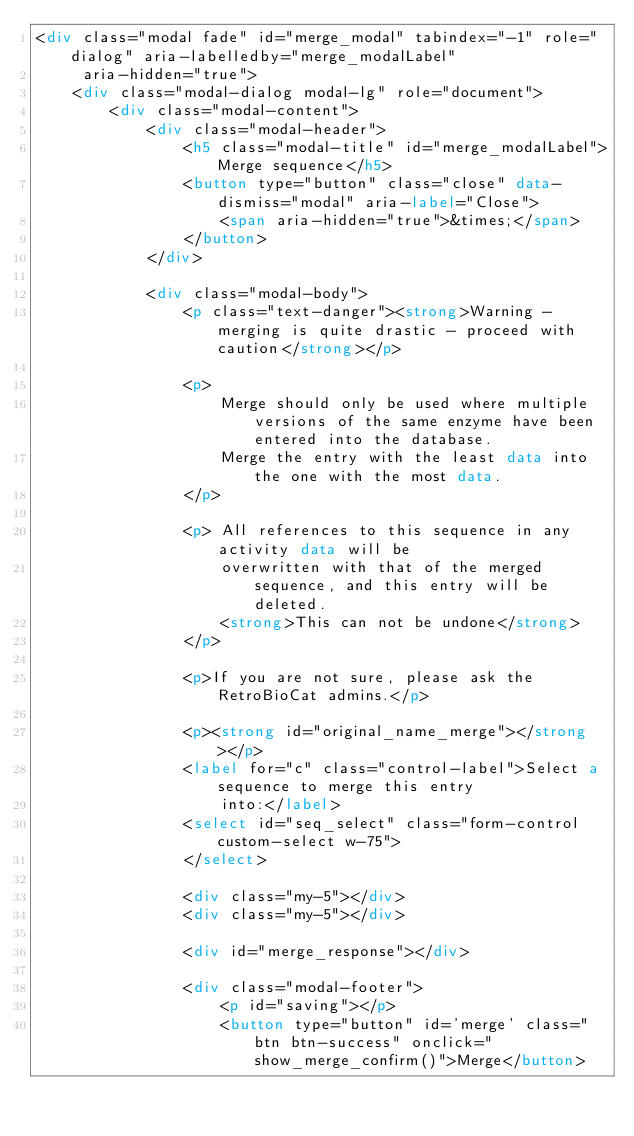<code> <loc_0><loc_0><loc_500><loc_500><_HTML_><div class="modal fade" id="merge_modal" tabindex="-1" role="dialog" aria-labelledby="merge_modalLabel"
     aria-hidden="true">
    <div class="modal-dialog modal-lg" role="document">
        <div class="modal-content">
            <div class="modal-header">
                <h5 class="modal-title" id="merge_modalLabel">Merge sequence</h5>
                <button type="button" class="close" data-dismiss="modal" aria-label="Close">
                    <span aria-hidden="true">&times;</span>
                </button>
            </div>

            <div class="modal-body">
                <p class="text-danger"><strong>Warning - merging is quite drastic - proceed with caution</strong></p>

                <p>
                    Merge should only be used where multiple versions of the same enzyme have been entered into the database.
                    Merge the entry with the least data into the one with the most data.
                </p>

                <p> All references to this sequence in any activity data will be
                    overwritten with that of the merged sequence, and this entry will be deleted.
                    <strong>This can not be undone</strong>
                </p>

                <p>If you are not sure, please ask the RetroBioCat admins.</p>

                <p><strong id="original_name_merge"></strong></p>
                <label for="c" class="control-label">Select a sequence to merge this entry
                    into:</label>
                <select id="seq_select" class="form-control custom-select w-75">
                </select>

                <div class="my-5"></div>
                <div class="my-5"></div>

                <div id="merge_response"></div>

                <div class="modal-footer">
                    <p id="saving"></p>
                    <button type="button" id='merge' class="btn btn-success" onclick="show_merge_confirm()">Merge</button></code> 